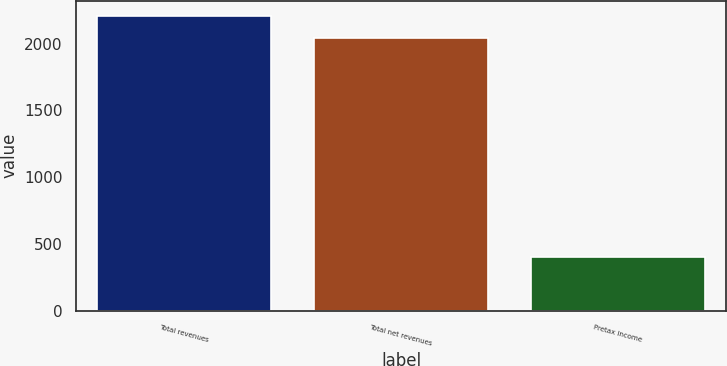<chart> <loc_0><loc_0><loc_500><loc_500><bar_chart><fcel>Total revenues<fcel>Total net revenues<fcel>Pretax income<nl><fcel>2210.5<fcel>2046<fcel>402<nl></chart> 